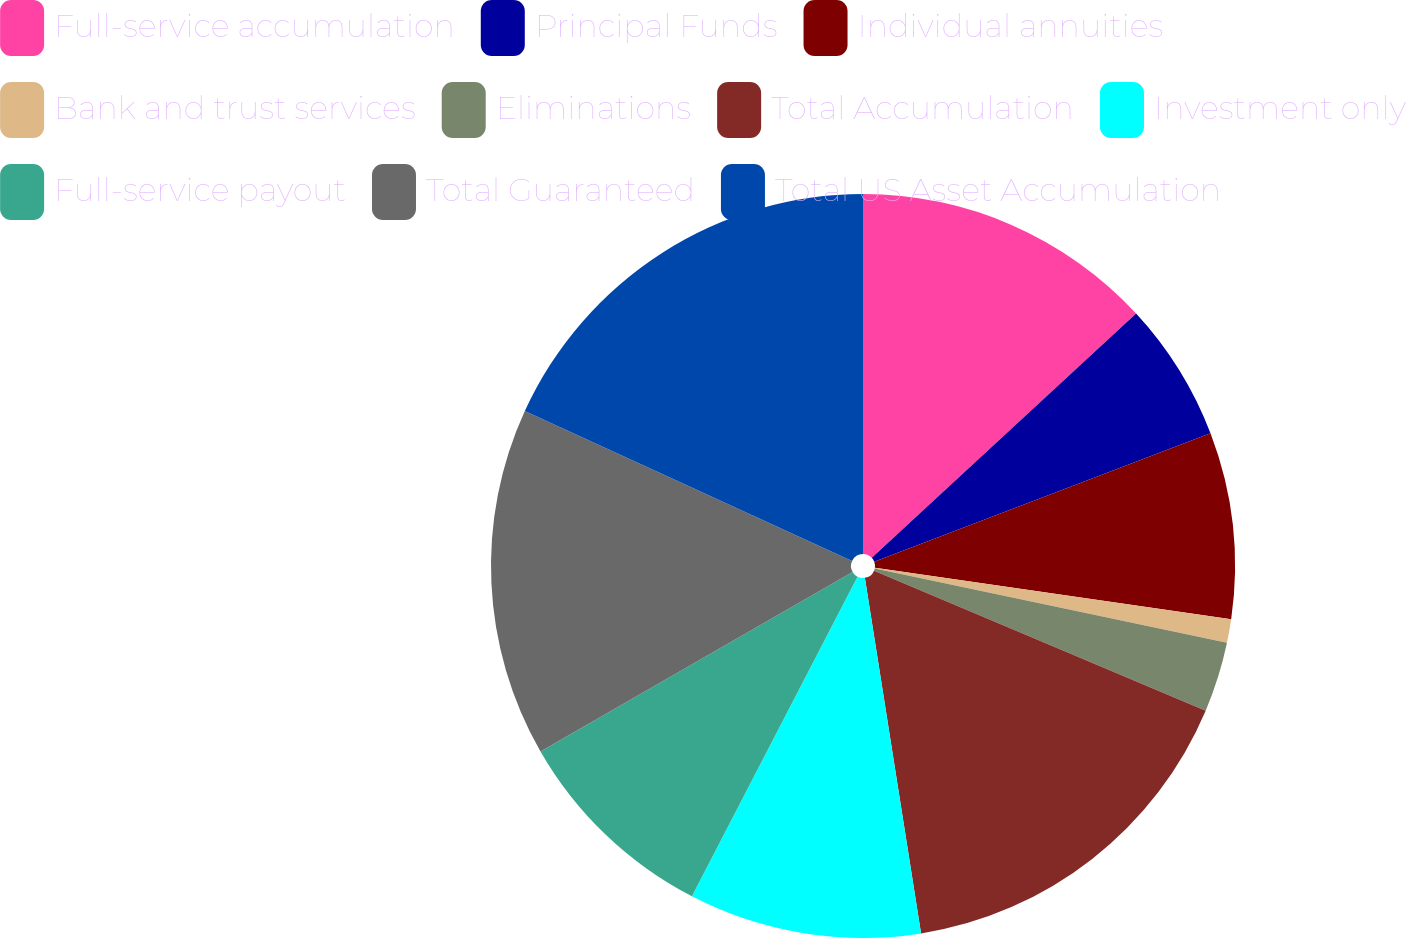<chart> <loc_0><loc_0><loc_500><loc_500><pie_chart><fcel>Full-service accumulation<fcel>Principal Funds<fcel>Individual annuities<fcel>Bank and trust services<fcel>Eliminations<fcel>Total Accumulation<fcel>Investment only<fcel>Full-service payout<fcel>Total Guaranteed<fcel>Total US Asset Accumulation<nl><fcel>13.12%<fcel>6.07%<fcel>8.09%<fcel>1.03%<fcel>3.05%<fcel>16.14%<fcel>10.1%<fcel>9.09%<fcel>15.14%<fcel>18.16%<nl></chart> 